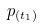Convert formula to latex. <formula><loc_0><loc_0><loc_500><loc_500>p _ { ( t _ { 1 } ) }</formula> 